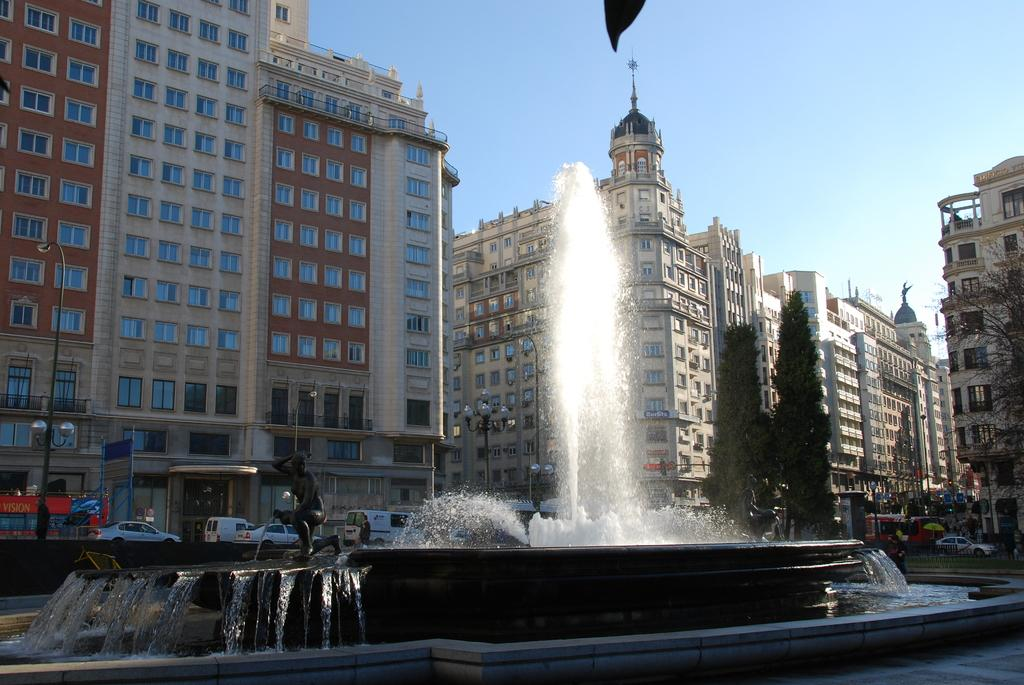What type of structures can be seen in the image? There are buildings in the image. What architectural features are present on the buildings? There are windows in the image. What are the poles used for in the image? The poles are likely used for supporting lights or other fixtures. Can you describe the lights in the image? Yes, there are lights in the image. What type of artwork is present in the image? There is a sculpture in the image. What type of water feature can be seen in the image? There is a water fountain in the image. What type of transportation is visible in the image? There are vehicles in the image. What type of vegetation is present in the image? There are trees in the image. What is visible in the background of the image? The sky is visible in the image. How many snakes are slithering around the water fountain in the image? There are no snakes present in the image; it features a water fountain and other elements mentioned in the facts. What type of seed is growing on the sculpture in the image? There is no seed growing on the sculpture in the image; it is a sculpture and not a plant. 